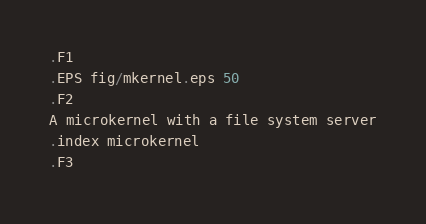Convert code to text. <code><loc_0><loc_0><loc_500><loc_500><_Perl_>.F1
.EPS fig/mkernel.eps 50
.F2
A microkernel with a file system server
.index microkernel
.F3
</code> 